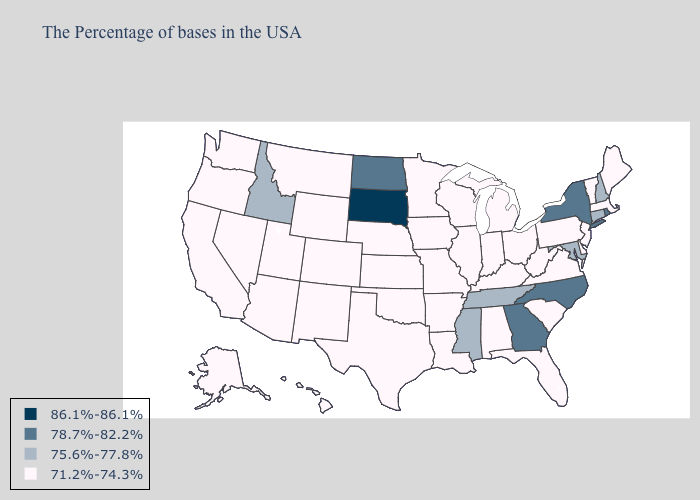Name the states that have a value in the range 78.7%-82.2%?
Keep it brief. Rhode Island, New York, North Carolina, Georgia, North Dakota. Name the states that have a value in the range 71.2%-74.3%?
Be succinct. Maine, Massachusetts, Vermont, New Jersey, Delaware, Pennsylvania, Virginia, South Carolina, West Virginia, Ohio, Florida, Michigan, Kentucky, Indiana, Alabama, Wisconsin, Illinois, Louisiana, Missouri, Arkansas, Minnesota, Iowa, Kansas, Nebraska, Oklahoma, Texas, Wyoming, Colorado, New Mexico, Utah, Montana, Arizona, Nevada, California, Washington, Oregon, Alaska, Hawaii. Name the states that have a value in the range 86.1%-86.1%?
Quick response, please. South Dakota. What is the value of Missouri?
Short answer required. 71.2%-74.3%. Name the states that have a value in the range 86.1%-86.1%?
Concise answer only. South Dakota. Among the states that border California , which have the lowest value?
Concise answer only. Arizona, Nevada, Oregon. Which states have the lowest value in the USA?
Write a very short answer. Maine, Massachusetts, Vermont, New Jersey, Delaware, Pennsylvania, Virginia, South Carolina, West Virginia, Ohio, Florida, Michigan, Kentucky, Indiana, Alabama, Wisconsin, Illinois, Louisiana, Missouri, Arkansas, Minnesota, Iowa, Kansas, Nebraska, Oklahoma, Texas, Wyoming, Colorado, New Mexico, Utah, Montana, Arizona, Nevada, California, Washington, Oregon, Alaska, Hawaii. Does Idaho have the lowest value in the West?
Answer briefly. No. Name the states that have a value in the range 86.1%-86.1%?
Short answer required. South Dakota. Does Oklahoma have the same value as Colorado?
Give a very brief answer. Yes. Does Pennsylvania have the lowest value in the Northeast?
Give a very brief answer. Yes. Which states hav the highest value in the South?
Keep it brief. North Carolina, Georgia. Among the states that border Virginia , does Kentucky have the highest value?
Give a very brief answer. No. Among the states that border Oregon , does Idaho have the lowest value?
Give a very brief answer. No. 